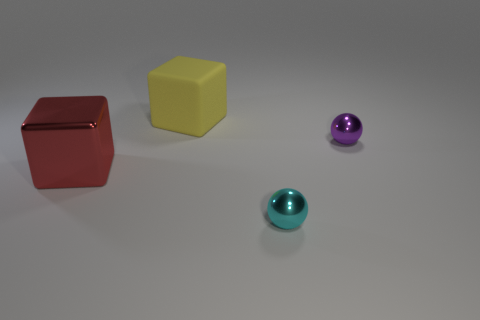How many other things are there of the same material as the yellow cube? Upon examining the image, it appears that there are no other objects made of the same material as the yellow cube, assuming we are distinguishing materials by their apparent texture and matte surface finish. 